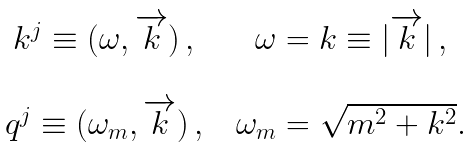<formula> <loc_0><loc_0><loc_500><loc_500>\begin{array} { c c c } k ^ { j } \equiv ( \omega , \overrightarrow { k } ) \, , & & \omega = k \equiv | \overrightarrow { k } | \, , \\ \\ q ^ { j } \equiv ( \omega _ { m } , \overrightarrow { k } ) \, , & & \omega _ { m } = \sqrt { m ^ { 2 } + k ^ { 2 } } . \end{array}</formula> 